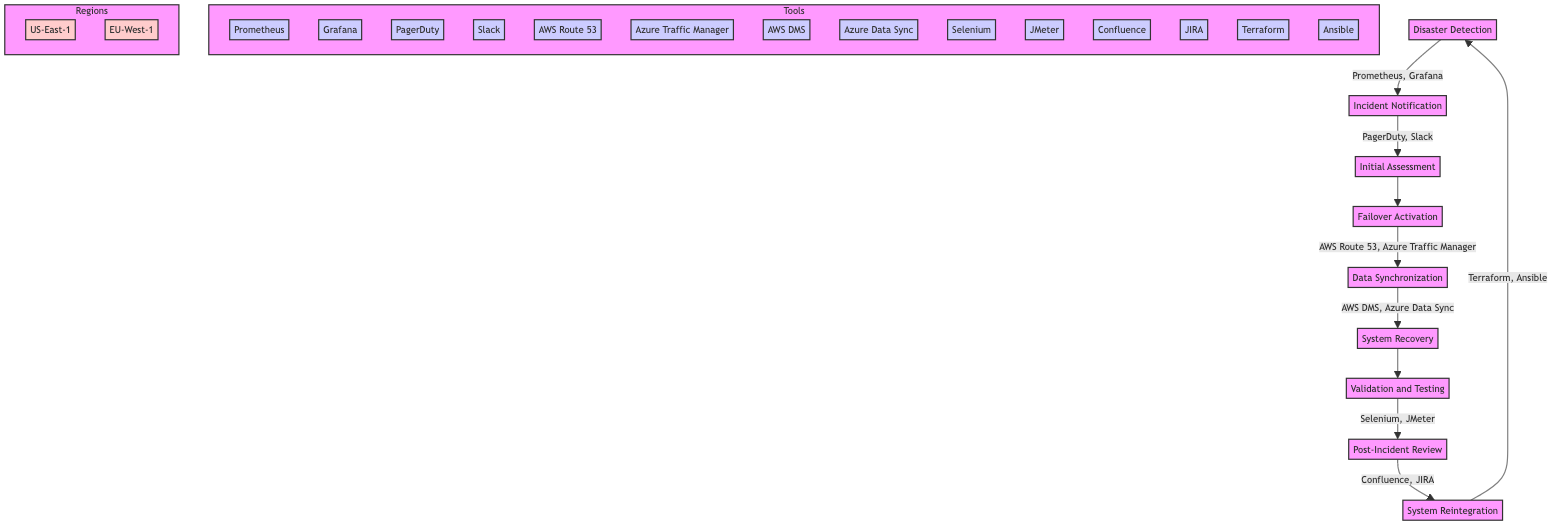What is the first step in the disaster recovery process? The diagram shows that the first step is "Disaster Detection". This is identified as the starting node at the top of the flow chart, leading into the subsequent steps.
Answer: Disaster Detection Which tools are used in the Failover Activation step? According to the diagram, the tools listed under the "Failover Activation" step include "Amazon Route 53" and "Azure Traffic Manager", which are directly connected to this step.
Answer: Amazon Route 53, Azure Traffic Manager How many geographic regions are mentioned in the failover activation process? The diagram specifies two geographic regions associated with the "Failover Activation" step: "US-East-1" and "EU-West-1". Counting these gives a total of two regions.
Answer: 2 What team is responsible for the Initial Assessment step? The diagram indicates that the teams involved in the "Initial Assessment" step are "Site Reliability Engineering (SRE)" and "Operations". This step includes this information clearly in its description.
Answer: Site Reliability Engineering, Operations What is the last step in the disaster recovery process? From the diagram, the last step listed is "System Reintegration". This step is the endpoint of the flow chart before returning to "Disaster Detection", closing the recovery loop.
Answer: System Reintegration Which step involves tools for testing the system's integrity and performance? The "Validation and Testing" step in the diagram explicitly states it employs "Selenium" and "JMeter" as tools to ensure the system performs correctly post-recovery.
Answer: Selenium, JMeter In the post-incident review, which teams are involved? The diagram indicates that the teams responsible for the "Post-Incident Review" are the "Incident Response Team" and "Management". This is shown in the description of this step.
Answer: Incident Response Team, Management What is the purpose of "Data Synchronization"? The diagram describes the "Data Synchronization" step as ensuring "data consistency between primary and failover systems using real-time replication", which outlines its critical functionality in the recovery process.
Answer: Ensure data consistency What connects the step "Validation and Testing" to "Post-Incident Review"? The diagram shows a direct arrow connecting "Validation and Testing" to "Post-Incident Review", indicating the flow of the process from validating system integrity to reviewing the incident after testing is complete.
Answer: Arrow connection 